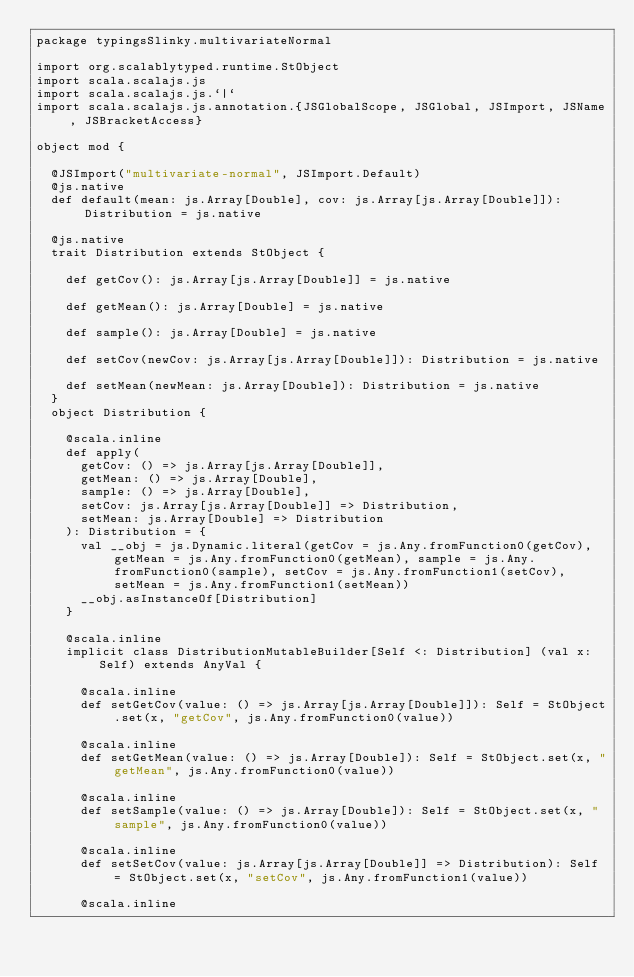Convert code to text. <code><loc_0><loc_0><loc_500><loc_500><_Scala_>package typingsSlinky.multivariateNormal

import org.scalablytyped.runtime.StObject
import scala.scalajs.js
import scala.scalajs.js.`|`
import scala.scalajs.js.annotation.{JSGlobalScope, JSGlobal, JSImport, JSName, JSBracketAccess}

object mod {
  
  @JSImport("multivariate-normal", JSImport.Default)
  @js.native
  def default(mean: js.Array[Double], cov: js.Array[js.Array[Double]]): Distribution = js.native
  
  @js.native
  trait Distribution extends StObject {
    
    def getCov(): js.Array[js.Array[Double]] = js.native
    
    def getMean(): js.Array[Double] = js.native
    
    def sample(): js.Array[Double] = js.native
    
    def setCov(newCov: js.Array[js.Array[Double]]): Distribution = js.native
    
    def setMean(newMean: js.Array[Double]): Distribution = js.native
  }
  object Distribution {
    
    @scala.inline
    def apply(
      getCov: () => js.Array[js.Array[Double]],
      getMean: () => js.Array[Double],
      sample: () => js.Array[Double],
      setCov: js.Array[js.Array[Double]] => Distribution,
      setMean: js.Array[Double] => Distribution
    ): Distribution = {
      val __obj = js.Dynamic.literal(getCov = js.Any.fromFunction0(getCov), getMean = js.Any.fromFunction0(getMean), sample = js.Any.fromFunction0(sample), setCov = js.Any.fromFunction1(setCov), setMean = js.Any.fromFunction1(setMean))
      __obj.asInstanceOf[Distribution]
    }
    
    @scala.inline
    implicit class DistributionMutableBuilder[Self <: Distribution] (val x: Self) extends AnyVal {
      
      @scala.inline
      def setGetCov(value: () => js.Array[js.Array[Double]]): Self = StObject.set(x, "getCov", js.Any.fromFunction0(value))
      
      @scala.inline
      def setGetMean(value: () => js.Array[Double]): Self = StObject.set(x, "getMean", js.Any.fromFunction0(value))
      
      @scala.inline
      def setSample(value: () => js.Array[Double]): Self = StObject.set(x, "sample", js.Any.fromFunction0(value))
      
      @scala.inline
      def setSetCov(value: js.Array[js.Array[Double]] => Distribution): Self = StObject.set(x, "setCov", js.Any.fromFunction1(value))
      
      @scala.inline</code> 